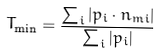Convert formula to latex. <formula><loc_0><loc_0><loc_500><loc_500>T _ { \min } = \frac { \sum _ { i } | { p } _ { i } \cdot { n } _ { m i } | } { \sum _ { i } | { p } _ { i } | }</formula> 